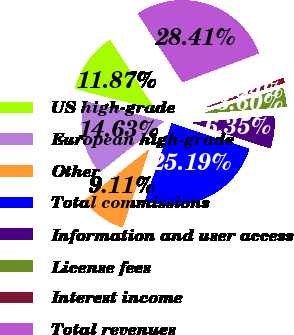Convert chart. <chart><loc_0><loc_0><loc_500><loc_500><pie_chart><fcel>US high-grade<fcel>European high-grade<fcel>Other<fcel>Total commissions<fcel>Information and user access<fcel>License fees<fcel>Interest income<fcel>Total revenues<nl><fcel>11.87%<fcel>14.63%<fcel>9.11%<fcel>25.19%<fcel>6.35%<fcel>3.6%<fcel>0.84%<fcel>28.41%<nl></chart> 